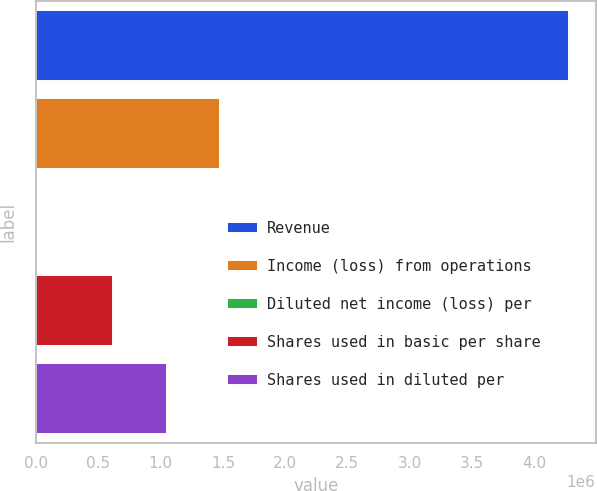Convert chart. <chart><loc_0><loc_0><loc_500><loc_500><bar_chart><fcel>Revenue<fcel>Income (loss) from operations<fcel>Diluted net income (loss) per<fcel>Shares used in basic per share<fcel>Shares used in diluted per<nl><fcel>4.28016e+06<fcel>1.47536e+06<fcel>0.9<fcel>619324<fcel>1.04734e+06<nl></chart> 